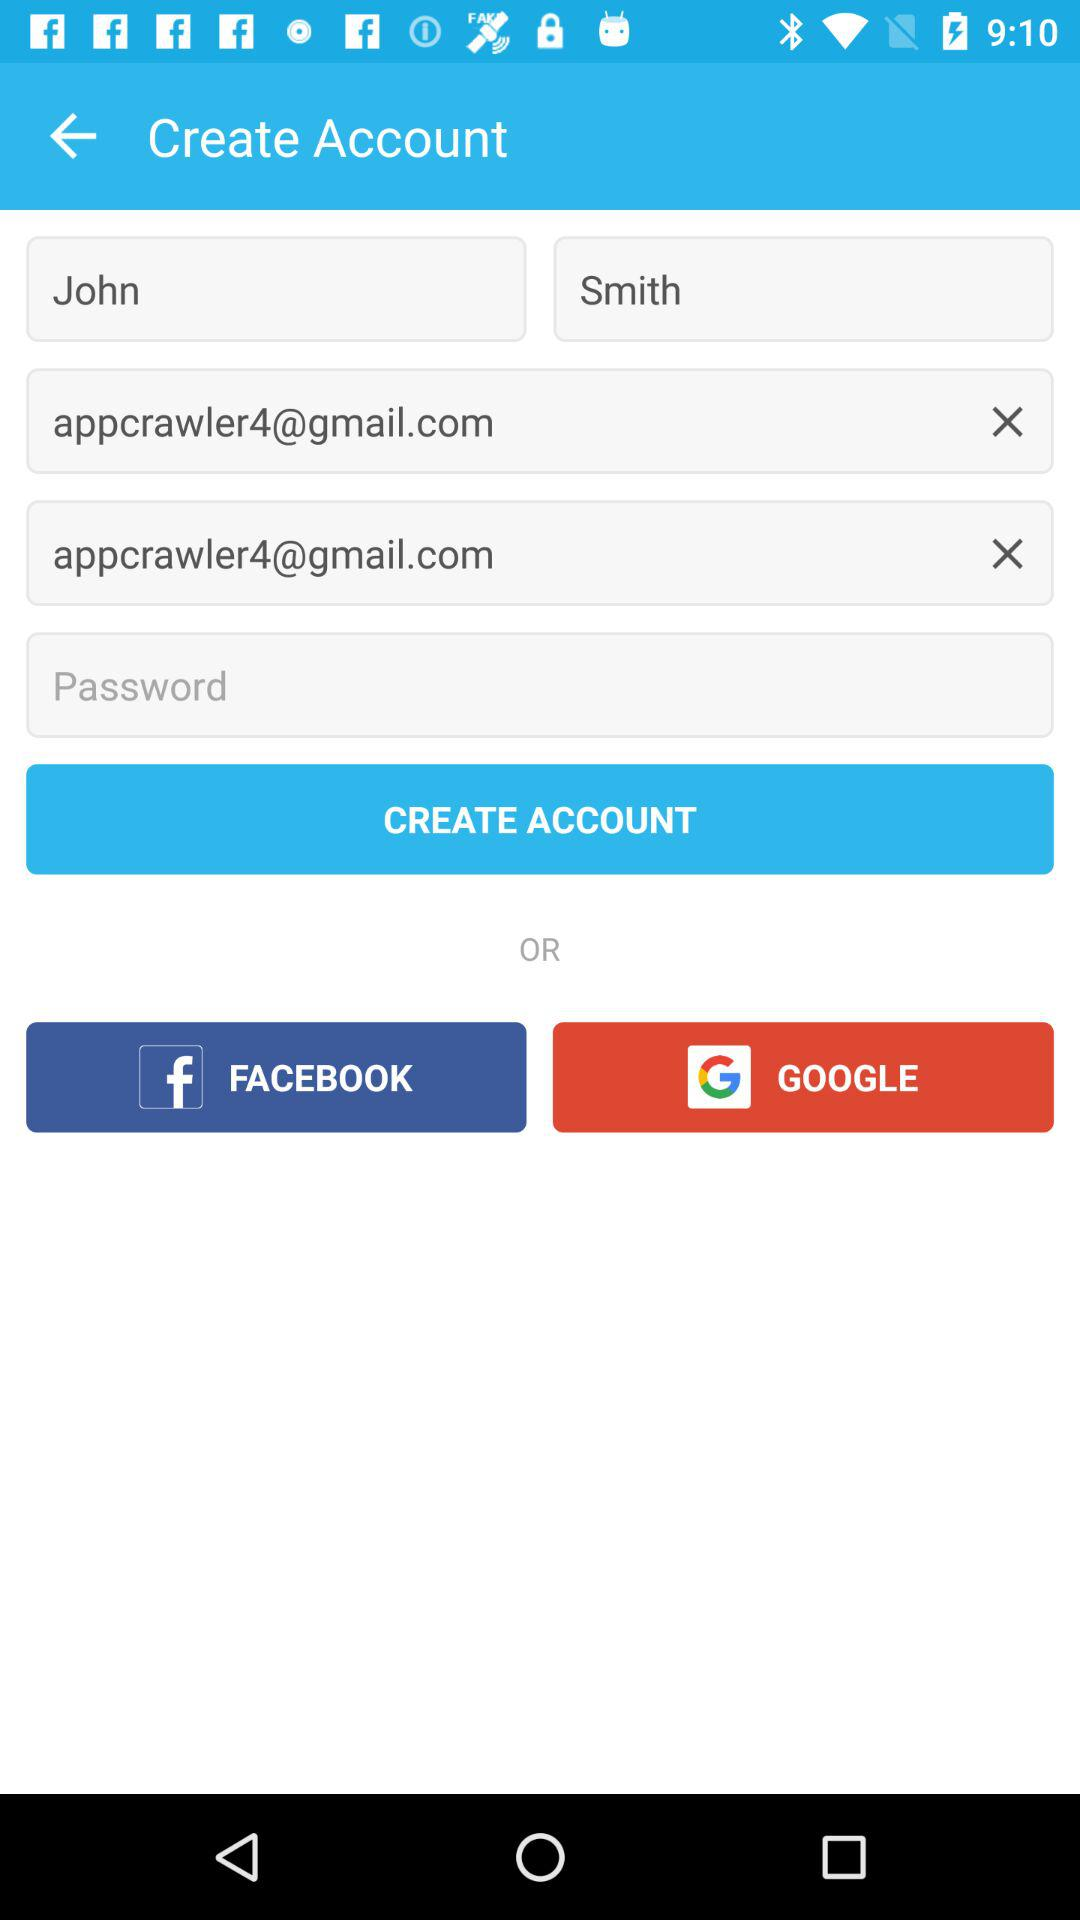How many email addresses are there on the screen?
Answer the question using a single word or phrase. 2 